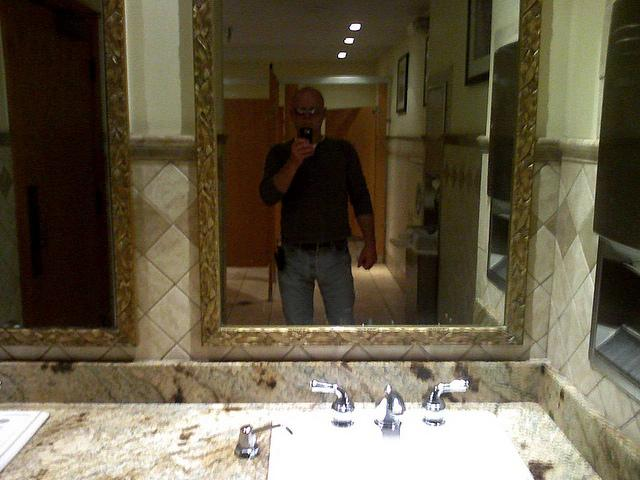Where does the man carry his cell phone?

Choices:
A) shirt pocket
B) jeans pocket
C) messenger bag
D) side holster side holster 